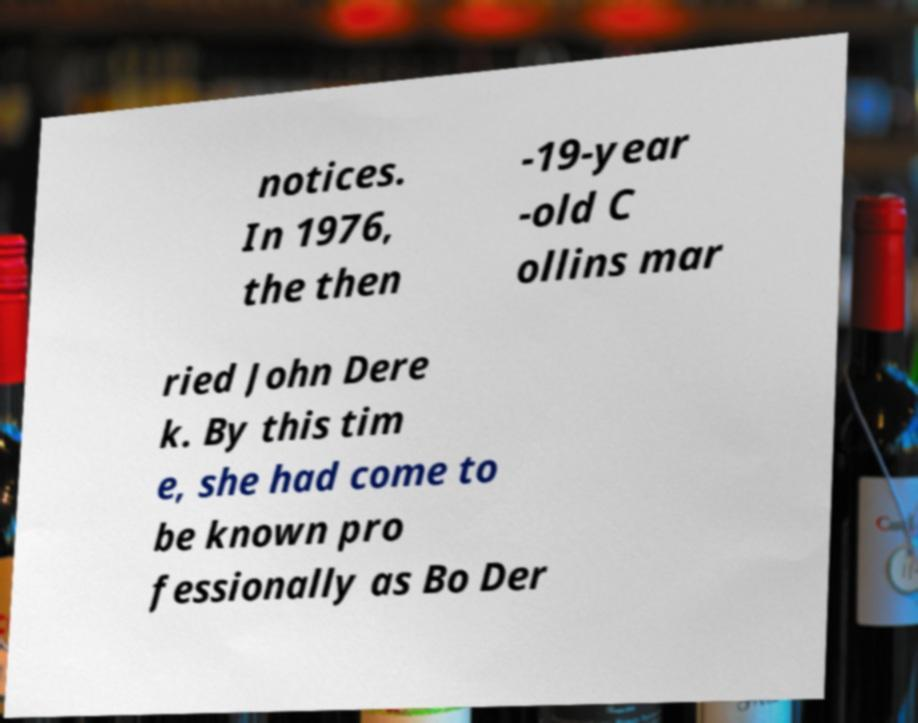For documentation purposes, I need the text within this image transcribed. Could you provide that? notices. In 1976, the then -19-year -old C ollins mar ried John Dere k. By this tim e, she had come to be known pro fessionally as Bo Der 